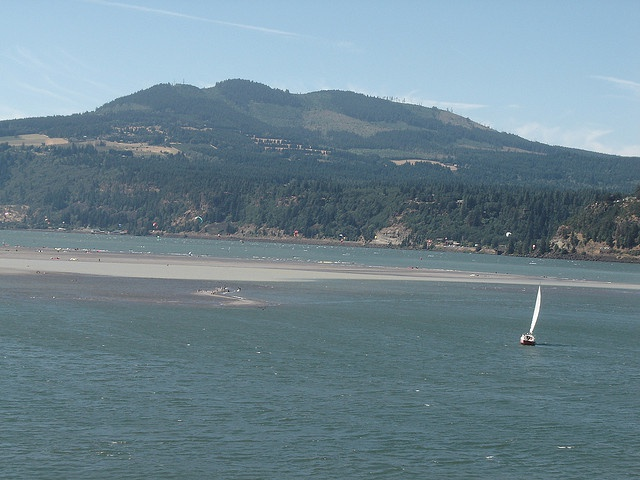Describe the objects in this image and their specific colors. I can see a boat in lightblue, white, gray, darkgray, and black tones in this image. 